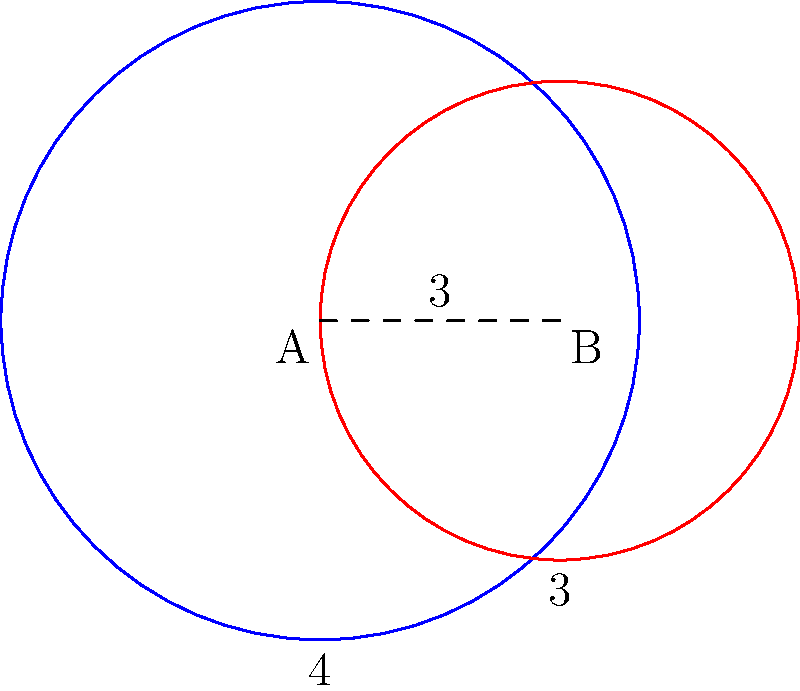In your latest superhero comic, two characters with circular force fields are engaged in battle. Hero A's force field has a radius of 4 units, while Villain B's force field has a radius of 3 units. The centers of their force fields are 3 units apart. What is the area of the region where their force fields overlap? This overlap represents the zone of most intense conflict in your story. Round your answer to two decimal places. To find the area of overlap between two intersecting circles, we can use the following steps:

1) First, we need to calculate the distance $d$ from the center of each circle to the line of intersection. We can use the formula:

   $d_1 = \frac{r_1^2 - r_2^2 + a^2}{2a}$ for circle 1
   $d_2 = a - d_1$ for circle 2

   Where $r_1 = 4$, $r_2 = 3$, and $a = 3$ (distance between centers)

2) $d_1 = \frac{4^2 - 3^2 + 3^2}{2(3)} = \frac{16 - 9 + 9}{6} = \frac{16}{6} = 2.67$
   $d_2 = 3 - 2.67 = 0.33$

3) Now we calculate the angle $\theta$ for each circle:
   $\theta_1 = 2 \arccos(\frac{d_1}{r_1}) = 2 \arccos(\frac{2.67}{4}) = 2.214$ radians
   $\theta_2 = 2 \arccos(\frac{d_2}{r_2}) = 2 \arccos(\frac{0.33}{3}) = 2.838$ radians

4) The area of the circular sector for each circle is:
   $A_1 = \frac{1}{2} r_1^2 \theta_1 = \frac{1}{2} (4^2) (2.214) = 17.712$
   $A_2 = \frac{1}{2} r_2^2 \theta_2 = \frac{1}{2} (3^2) (2.838) = 12.771$

5) The area of the triangle for each circle is:
   $T_1 = d_1 \sqrt{r_1^2 - d_1^2} = 2.67 \sqrt{4^2 - 2.67^2} = 6.568$
   $T_2 = d_2 \sqrt{r_2^2 - d_2^2} = 0.33 \sqrt{3^2 - 0.33^2} = 0.990$

6) The area of overlap is the sum of the circular sectors minus the sum of the triangles:
   Overlap Area = $(A_1 + A_2) - (T_1 + T_2)$
                = $(17.712 + 12.771) - (6.568 + 0.990)$
                = $30.483 - 7.558$
                = $22.925$

7) Rounding to two decimal places: 22.93 square units.
Answer: 22.93 square units 